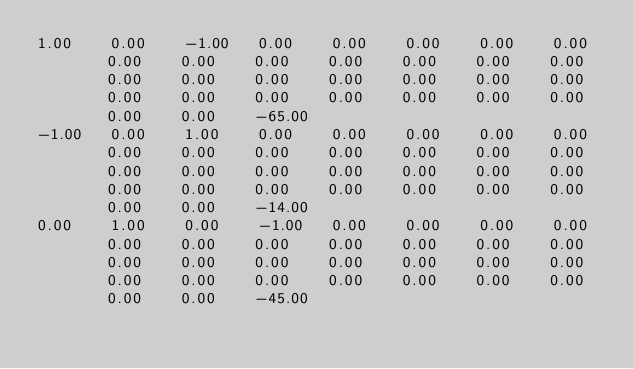<code> <loc_0><loc_0><loc_500><loc_500><_Matlab_>1.00	0.00	-1.00	0.00	0.00	0.00	0.00	0.00	0.00	0.00	0.00	0.00	0.00	0.00	0.00	0.00	0.00	0.00	0.00	0.00	0.00	0.00	0.00	0.00	0.00	0.00	0.00	0.00	0.00	0.00	0.00	-65.00
-1.00	0.00	1.00	0.00	0.00	0.00	0.00	0.00	0.00	0.00	0.00	0.00	0.00	0.00	0.00	0.00	0.00	0.00	0.00	0.00	0.00	0.00	0.00	0.00	0.00	0.00	0.00	0.00	0.00	0.00	0.00	-14.00
0.00	1.00	0.00	-1.00	0.00	0.00	0.00	0.00	0.00	0.00	0.00	0.00	0.00	0.00	0.00	0.00	0.00	0.00	0.00	0.00	0.00	0.00	0.00	0.00	0.00	0.00	0.00	0.00	0.00	0.00	0.00	-45.00</code> 